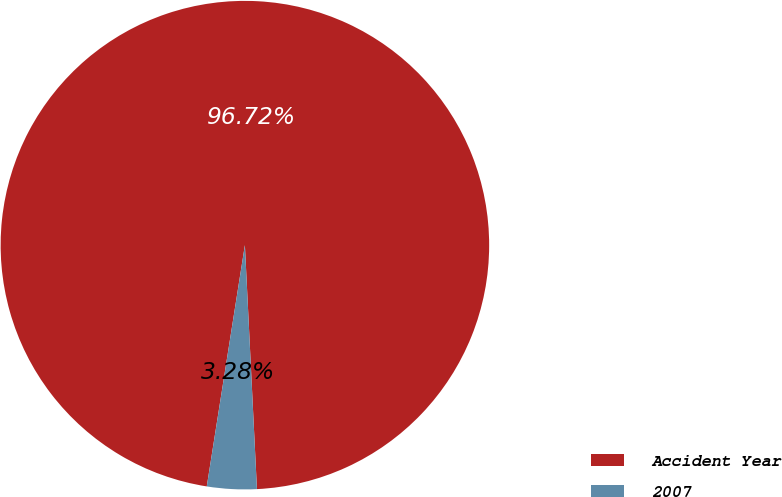<chart> <loc_0><loc_0><loc_500><loc_500><pie_chart><fcel>Accident Year<fcel>2007<nl><fcel>96.72%<fcel>3.28%<nl></chart> 